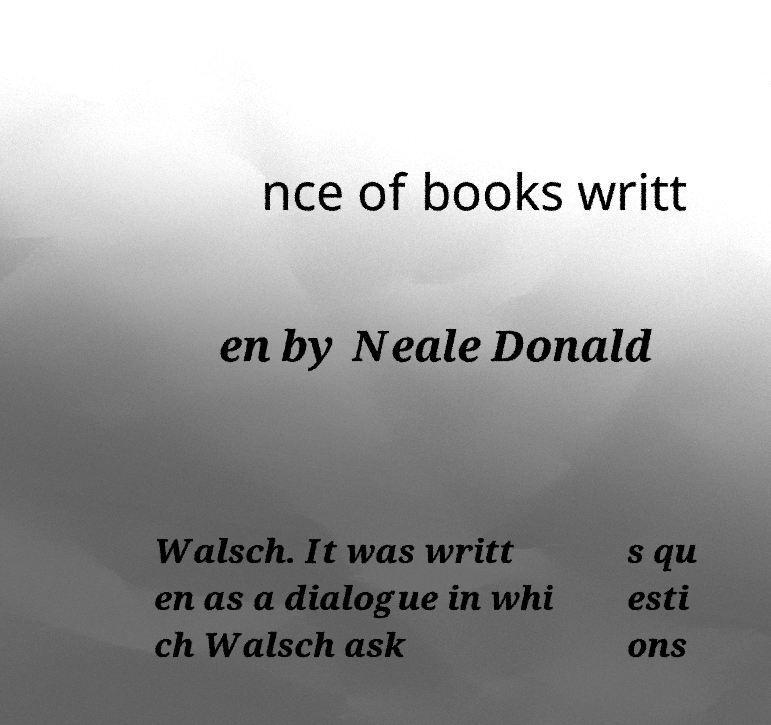What messages or text are displayed in this image? I need them in a readable, typed format. nce of books writt en by Neale Donald Walsch. It was writt en as a dialogue in whi ch Walsch ask s qu esti ons 